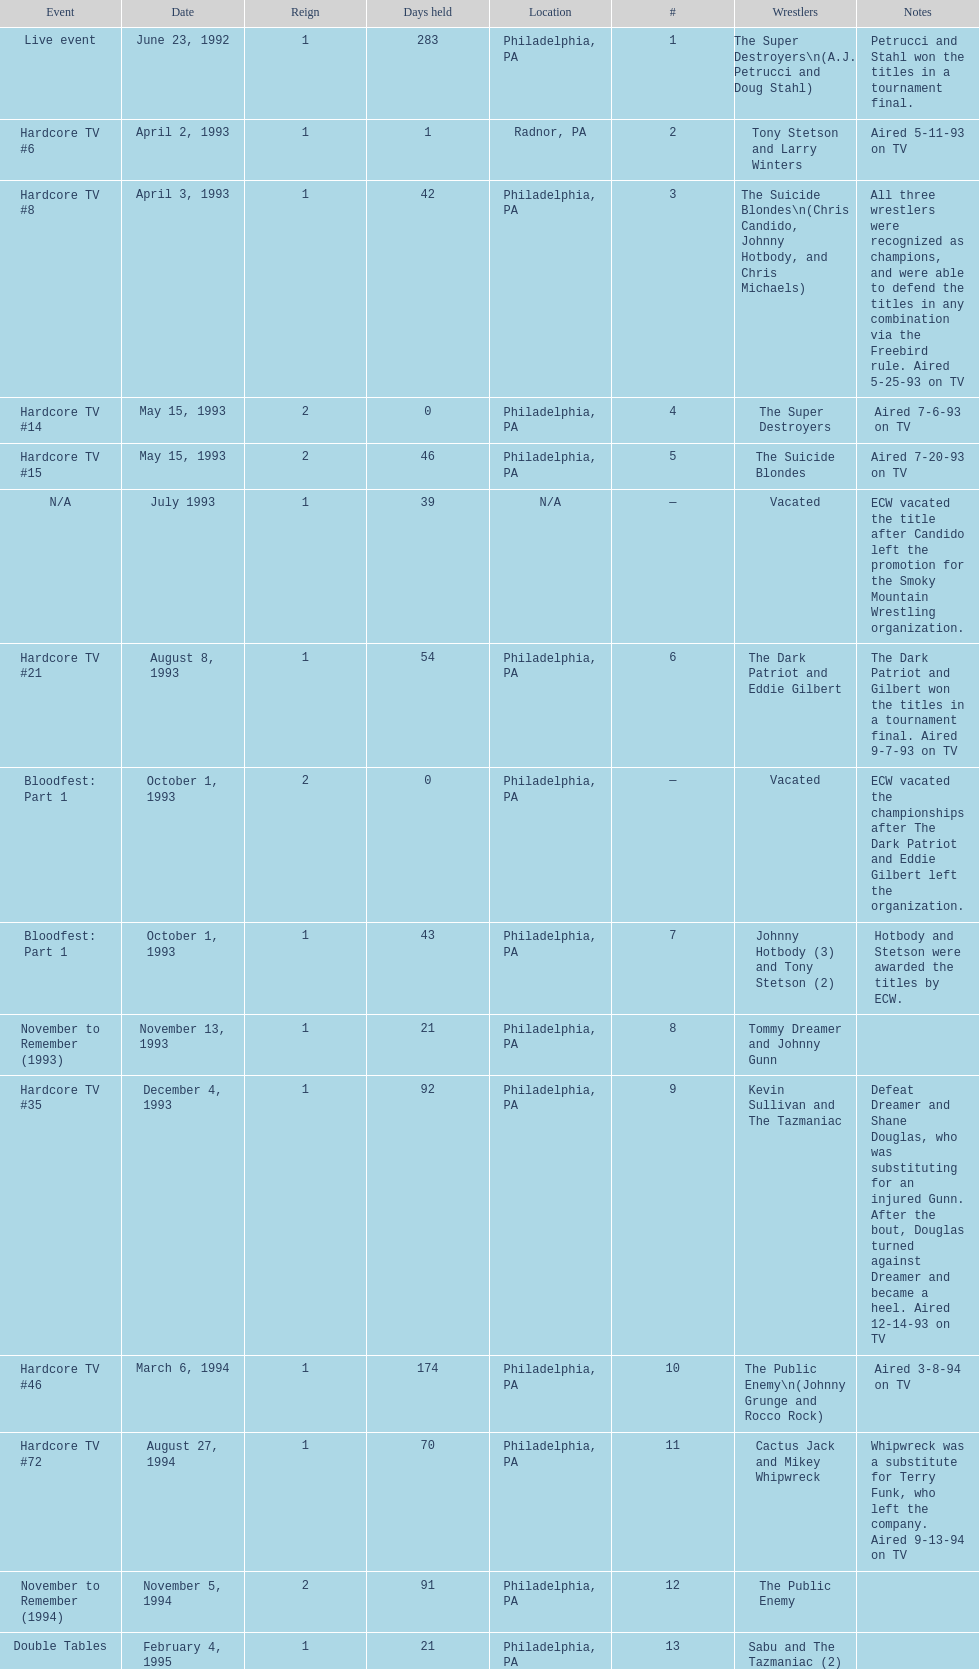How many times, from june 23, 1992 to december 3, 2000, did the suicide blondes hold the title? 2. 